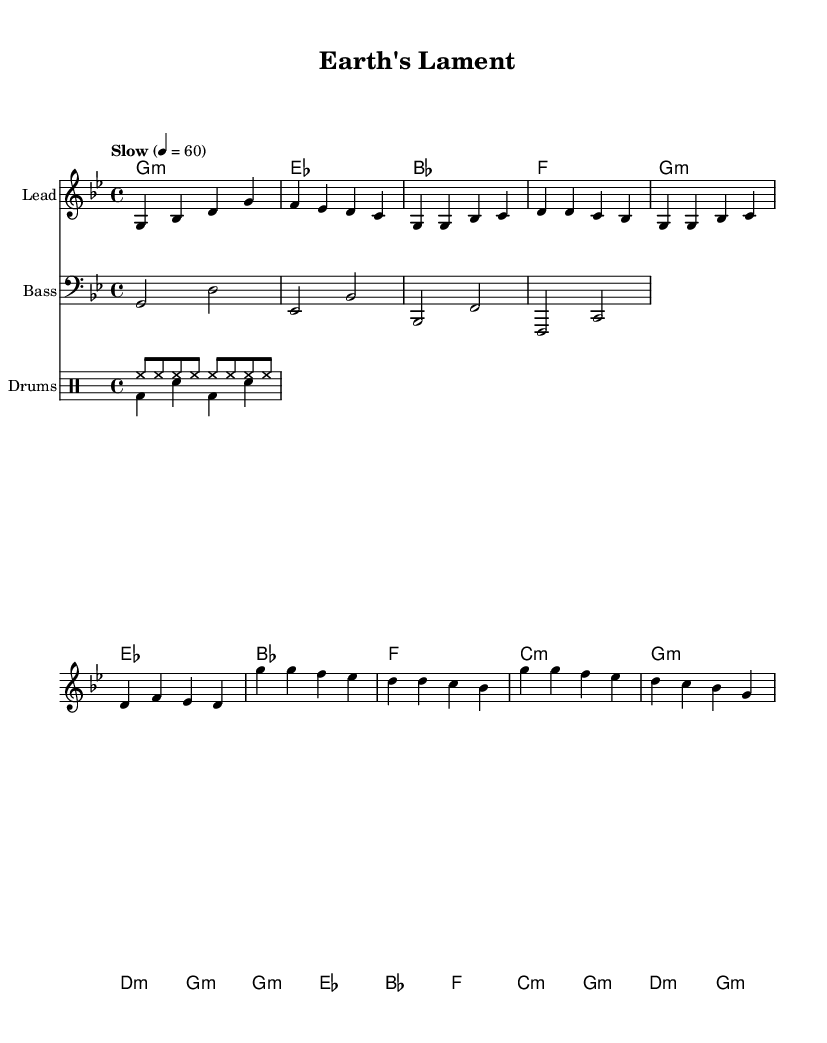What is the key signature of this music? The key signature is indicated by the two flats shown at the beginning of the staff which correspond to G minor.
Answer: G minor What is the time signature of the piece? The time signature is found at the beginning of the staff and it shows four beats in each measure, represented by the "4/4".
Answer: 4/4 What tempo marking is indicated for this piece? The tempo marking written above the staff specifies "Slow" with a quarter note equaling 60 beats per minute.
Answer: Slow, 60 How many measures are in the verse section? Counting the measures provided for the verse section, there are a total of 8 measures represented in the melody.
Answer: 8 What is the primary theme explored in the lyrics? The lyrics express concerns about environmental issues, particularly emphasizing the pain experienced by Mother Earth.
Answer: Environmental conservation What is the chord progression used in the chorus? The chord progression for the chorus consists of the chords indicated in the harmonies section, which are G minor, E flat, B flat, and F.
Answer: G minor, E flat, B flat, F What type of drum pattern is used throughout the piece? The drum pattern includes both a hi-hat loop and a bass drum-snare pattern, typical in rhythm and blues, creating a steady groove.
Answer: Hi-hat and bass-snare pattern 